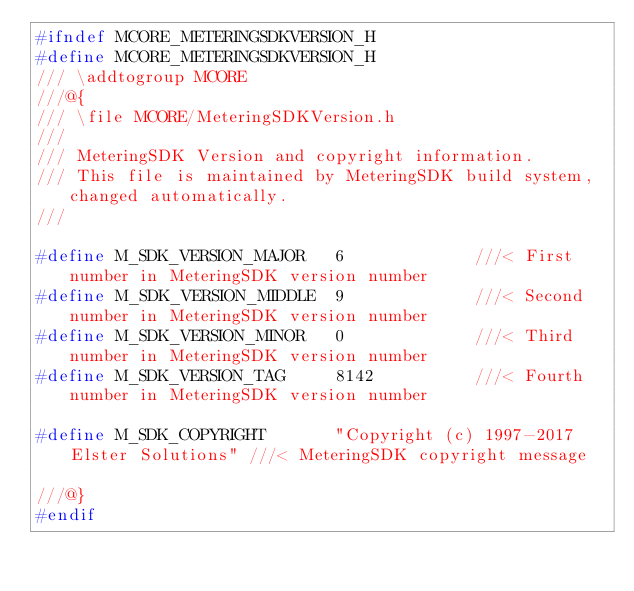<code> <loc_0><loc_0><loc_500><loc_500><_C_>#ifndef MCORE_METERINGSDKVERSION_H
#define MCORE_METERINGSDKVERSION_H
/// \addtogroup MCORE
///@{
/// \file MCORE/MeteringSDKVersion.h
///
/// MeteringSDK Version and copyright information.
/// This file is maintained by MeteringSDK build system, changed automatically.
///

#define M_SDK_VERSION_MAJOR   6             ///< First number in MeteringSDK version number
#define M_SDK_VERSION_MIDDLE  9             ///< Second number in MeteringSDK version number
#define M_SDK_VERSION_MINOR   0             ///< Third number in MeteringSDK version number
#define M_SDK_VERSION_TAG     8142          ///< Fourth number in MeteringSDK version number

#define M_SDK_COPYRIGHT       "Copyright (c) 1997-2017 Elster Solutions" ///< MeteringSDK copyright message

///@}
#endif
</code> 